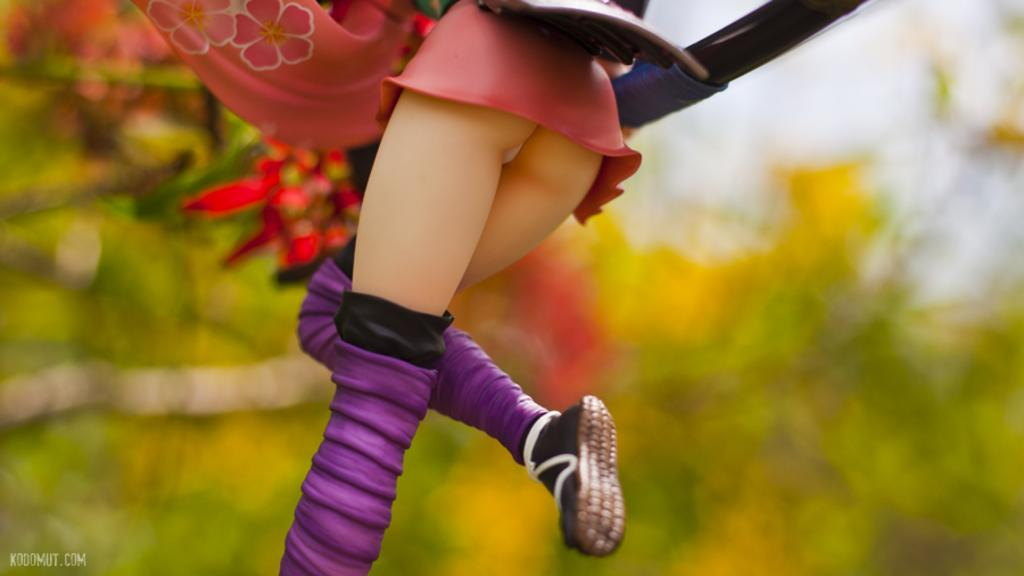Who is present in the image? There is a person in the image. What is the person wearing? The person is wearing a pink dress and purple boots. What can be seen in the background of the image? There are trees in the background of the image. How would you describe the background in the image? The background is blurry. Can you hear the person singing in the image? There is no indication of sound or singing in the image, as it is a still photograph. Is the person in danger of sinking into quicksand in the image? There is no quicksand present in the image, and the person is standing on solid ground. 